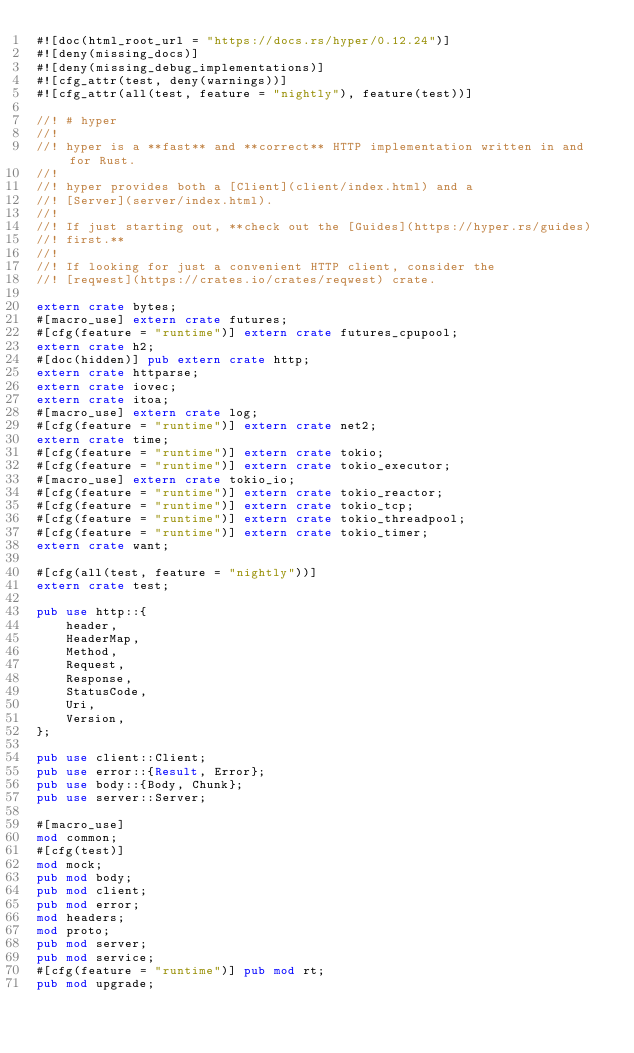Convert code to text. <code><loc_0><loc_0><loc_500><loc_500><_Rust_>#![doc(html_root_url = "https://docs.rs/hyper/0.12.24")]
#![deny(missing_docs)]
#![deny(missing_debug_implementations)]
#![cfg_attr(test, deny(warnings))]
#![cfg_attr(all(test, feature = "nightly"), feature(test))]

//! # hyper
//!
//! hyper is a **fast** and **correct** HTTP implementation written in and for Rust.
//!
//! hyper provides both a [Client](client/index.html) and a
//! [Server](server/index.html).
//!
//! If just starting out, **check out the [Guides](https://hyper.rs/guides)
//! first.**
//!
//! If looking for just a convenient HTTP client, consider the
//! [reqwest](https://crates.io/crates/reqwest) crate.

extern crate bytes;
#[macro_use] extern crate futures;
#[cfg(feature = "runtime")] extern crate futures_cpupool;
extern crate h2;
#[doc(hidden)] pub extern crate http;
extern crate httparse;
extern crate iovec;
extern crate itoa;
#[macro_use] extern crate log;
#[cfg(feature = "runtime")] extern crate net2;
extern crate time;
#[cfg(feature = "runtime")] extern crate tokio;
#[cfg(feature = "runtime")] extern crate tokio_executor;
#[macro_use] extern crate tokio_io;
#[cfg(feature = "runtime")] extern crate tokio_reactor;
#[cfg(feature = "runtime")] extern crate tokio_tcp;
#[cfg(feature = "runtime")] extern crate tokio_threadpool;
#[cfg(feature = "runtime")] extern crate tokio_timer;
extern crate want;

#[cfg(all(test, feature = "nightly"))]
extern crate test;

pub use http::{
    header,
    HeaderMap,
    Method,
    Request,
    Response,
    StatusCode,
    Uri,
    Version,
};

pub use client::Client;
pub use error::{Result, Error};
pub use body::{Body, Chunk};
pub use server::Server;

#[macro_use]
mod common;
#[cfg(test)]
mod mock;
pub mod body;
pub mod client;
pub mod error;
mod headers;
mod proto;
pub mod server;
pub mod service;
#[cfg(feature = "runtime")] pub mod rt;
pub mod upgrade;
</code> 